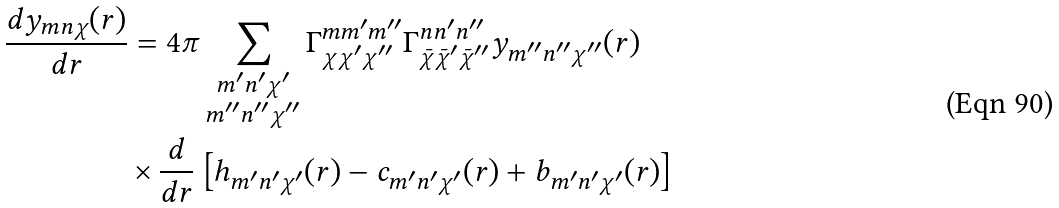<formula> <loc_0><loc_0><loc_500><loc_500>\frac { d y _ { m n \chi } ( r ) } { d r } & = 4 \pi \sum _ { \substack { m ^ { \prime } n ^ { \prime } \chi ^ { \prime } \\ m ^ { \prime \prime } n ^ { \prime \prime } \chi ^ { \prime \prime } } } \Gamma ^ { m m ^ { \prime } m ^ { \prime \prime } } _ { \chi \chi ^ { \prime } \chi ^ { \prime \prime } } \Gamma ^ { n n ^ { \prime } n ^ { \prime \prime } } _ { \bar { \chi } \bar { \chi } ^ { \prime } \bar { \chi } ^ { \prime \prime } } y _ { m ^ { \prime \prime } n ^ { \prime \prime } \chi ^ { \prime \prime } } ( r ) \\ & \times \frac { d } { d r } \left [ h _ { m ^ { \prime } n ^ { \prime } \chi ^ { \prime } } ( r ) - c _ { m ^ { \prime } n ^ { \prime } \chi ^ { \prime } } ( r ) + b _ { m ^ { \prime } n ^ { \prime } \chi ^ { \prime } } ( r ) \right ]</formula> 